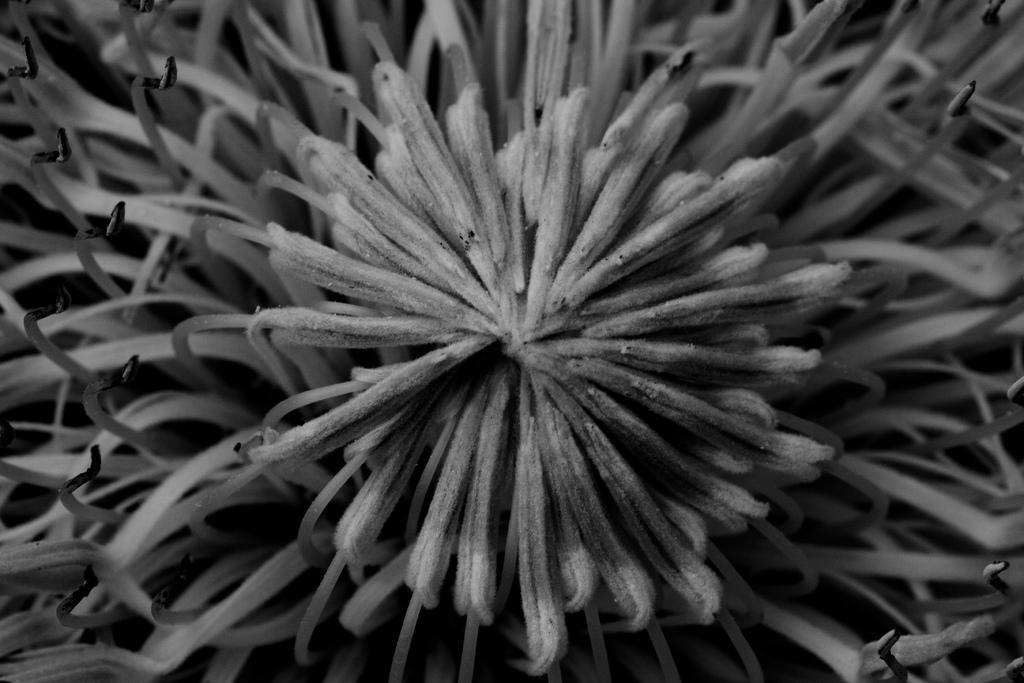What is the color scheme of the image? The image is black and white. What type of object can be seen in the image? There is a flower in the image. What type of pleasure can be seen in the image? There is no pleasure present in the image; it is a black and white image of a flower. 